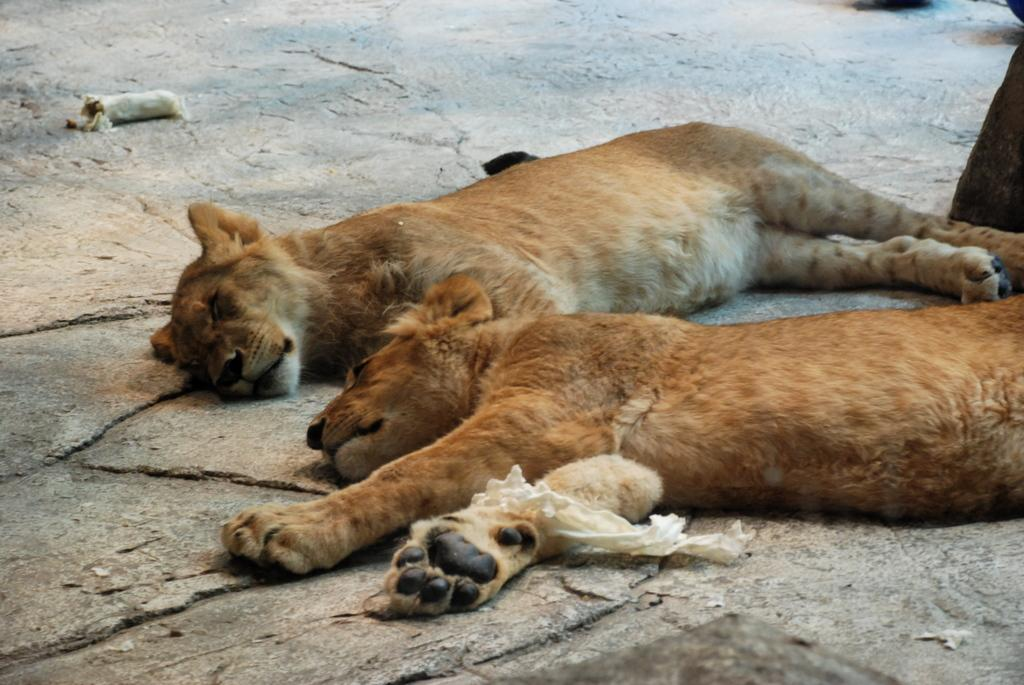What animals are present in the image? There are tigers in the image. What are the tigers doing in the image? The tigers are sleeping in the image. Where are the tigers located in the image? The tigers are on the floor in the image. What is the size of the yard in the image? There is no yard present in the image; it features tigers sleeping on the floor. 